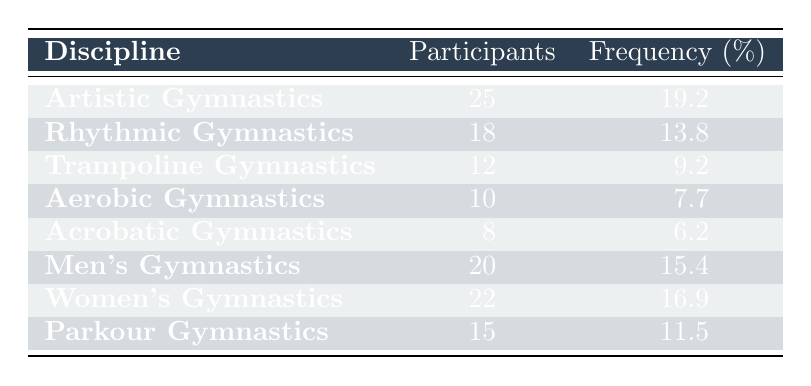What is the total number of participants across all gymnastics disciplines? To find the total number of participants, we sum the participants from each discipline: 25 + 18 + 12 + 10 + 8 + 20 + 22 + 15 = 120.
Answer: 120 Which discipline has the highest number of participants? The discipline with the highest number of participants is Artistic Gymnastics, with 25 participants.
Answer: Artistic Gymnastics What percentage of participants are involved in Trampoline Gymnastics? Trampoline Gymnastics has 12 participants. The frequency percentage for this discipline is 9.2%.
Answer: 9.2% Is there a difference in the number of participants between Women's Gymnastics and Men's Gymnastics? Yes, Women's Gymnastics has 22 participants and Men's Gymnastics has 20 participants. The difference is 22 - 20 = 2.
Answer: Yes, the difference is 2 What is the average number of participants in competition disciplines other than Artistic and Women's Gymnastics? First, we calculate the total participants for the remaining disciplines: 18 + 12 + 10 + 8 + 20 + 15 = 83. There are six disciplines, hence the average is 83/6 = 13.83.
Answer: 13.83 How many more participants are there in Rhythmic Gymnastics compared to Acrobatic Gymnastics? Rhythmic Gymnastics has 18 participants and Acrobatic Gymnastics has 8. The difference is 18 - 8 = 10 more participants in Rhythmic Gymnastics.
Answer: 10 Is the number of participants in Aerobic Gymnastics less than that in Parkour Gymnastics? Aerobic Gymnastics has 10 participants while Parkour Gymnastics has 15 participants. Since 10 is less than 15, the statement is true.
Answer: Yes What percentage of participants are involved in Acrobatic Gymnastics and Aerobic Gymnastics combined? Acrobatic Gymnastics has 8 participants and Aerobic Gymnastics has 10, totaling 8 + 10 = 18. The combined percentage of participants is (18/120) * 100 = 15%.
Answer: 15% 